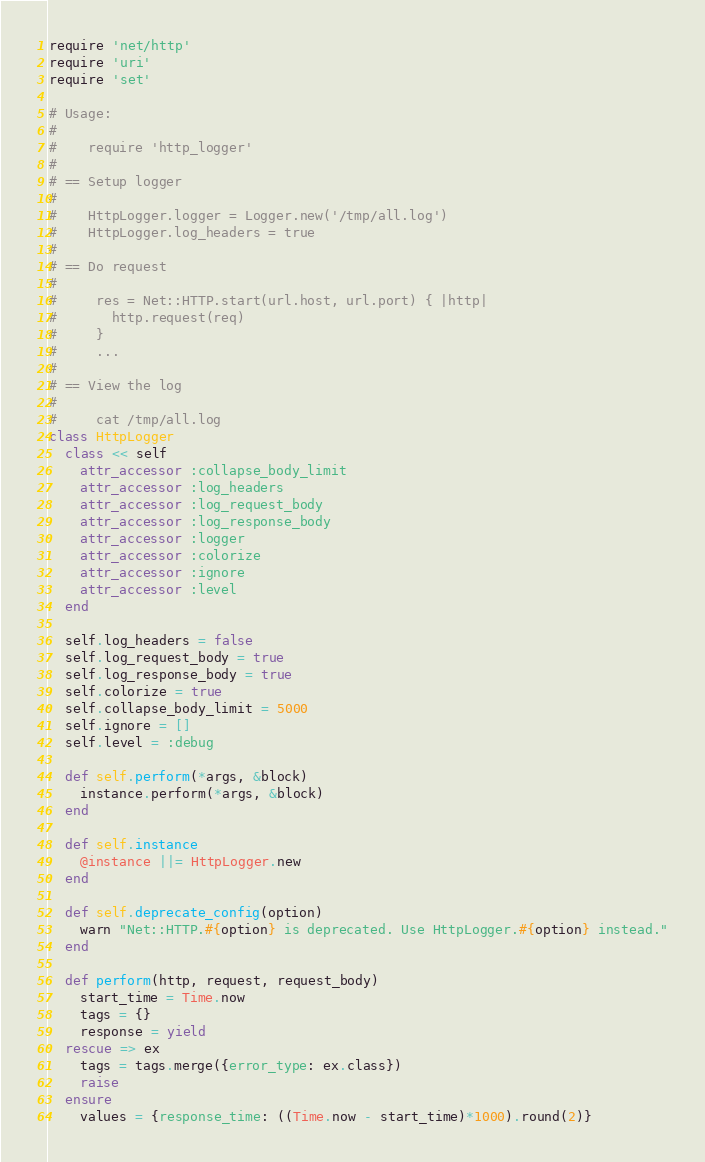Convert code to text. <code><loc_0><loc_0><loc_500><loc_500><_Ruby_>require 'net/http'
require 'uri'
require 'set'

# Usage:
#
#    require 'http_logger'
#
# == Setup logger
#
#    HttpLogger.logger = Logger.new('/tmp/all.log')
#    HttpLogger.log_headers = true
#
# == Do request
#
#     res = Net::HTTP.start(url.host, url.port) { |http|
#       http.request(req)
#     }
#     ...
#
# == View the log
#
#     cat /tmp/all.log
class HttpLogger
  class << self
    attr_accessor :collapse_body_limit
    attr_accessor :log_headers
    attr_accessor :log_request_body
    attr_accessor :log_response_body
    attr_accessor :logger
    attr_accessor :colorize
    attr_accessor :ignore
    attr_accessor :level
  end

  self.log_headers = false
  self.log_request_body = true
  self.log_response_body = true
  self.colorize = true
  self.collapse_body_limit = 5000
  self.ignore = []
  self.level = :debug

  def self.perform(*args, &block)
    instance.perform(*args, &block)
  end

  def self.instance
    @instance ||= HttpLogger.new
  end

  def self.deprecate_config(option)
    warn "Net::HTTP.#{option} is deprecated. Use HttpLogger.#{option} instead."
  end

  def perform(http, request, request_body)
    start_time = Time.now
    tags = {}
    response = yield
  rescue => ex
    tags = tags.merge({error_type: ex.class})
    raise
  ensure
    values = {response_time: ((Time.now - start_time)*1000).round(2)}</code> 